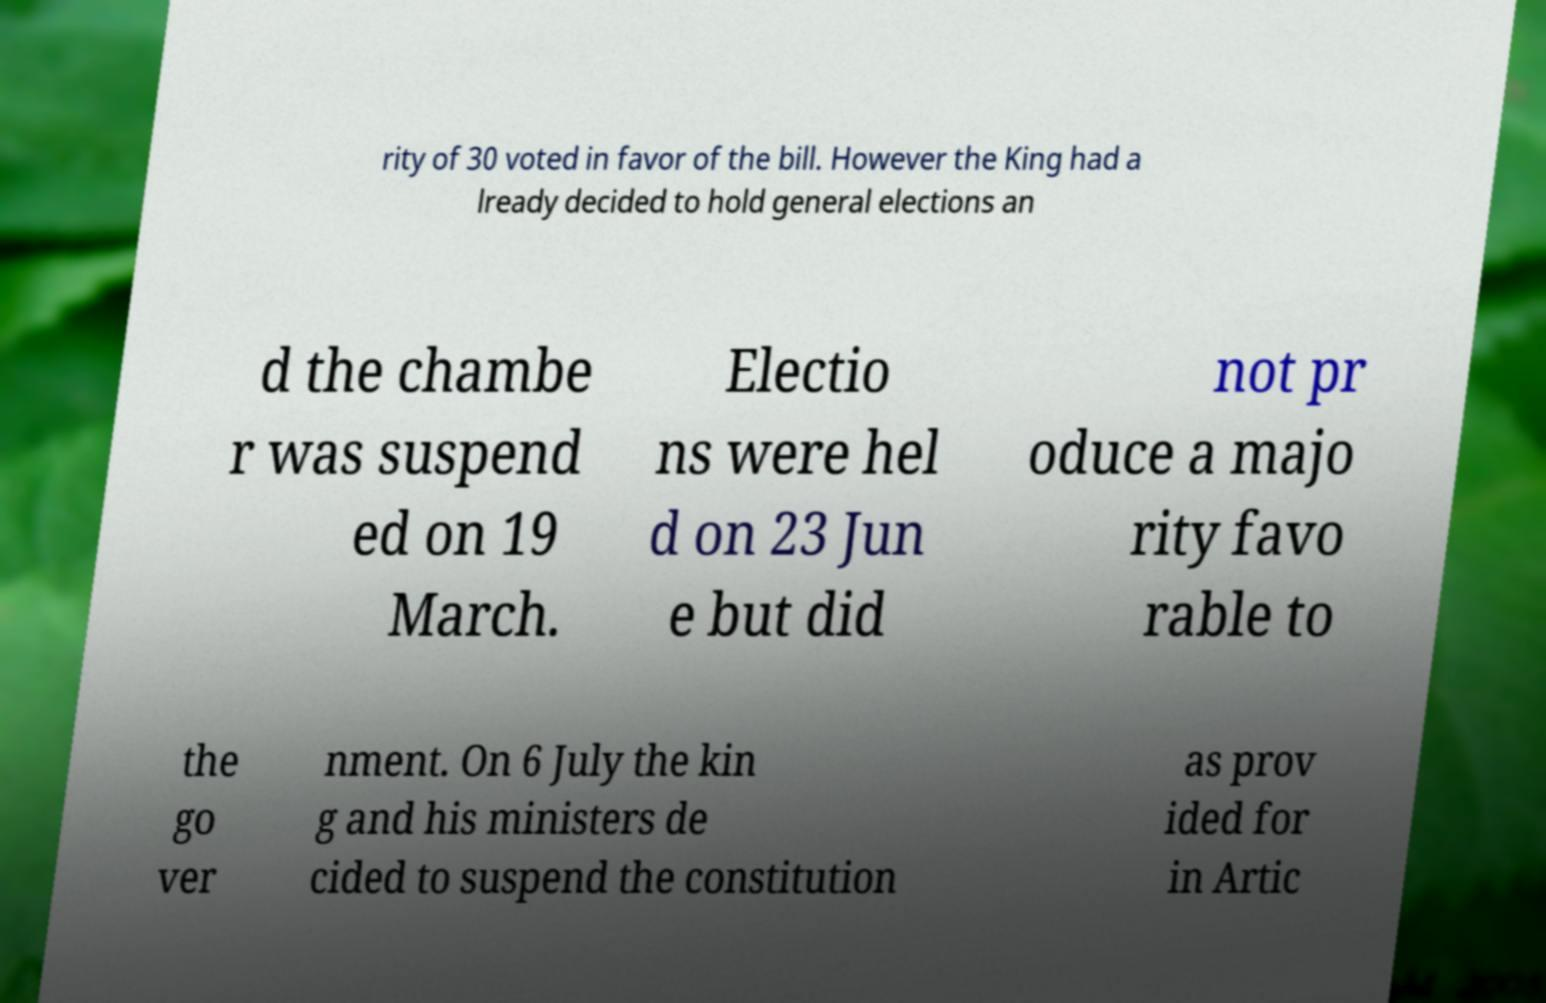Could you extract and type out the text from this image? rity of 30 voted in favor of the bill. However the King had a lready decided to hold general elections an d the chambe r was suspend ed on 19 March. Electio ns were hel d on 23 Jun e but did not pr oduce a majo rity favo rable to the go ver nment. On 6 July the kin g and his ministers de cided to suspend the constitution as prov ided for in Artic 